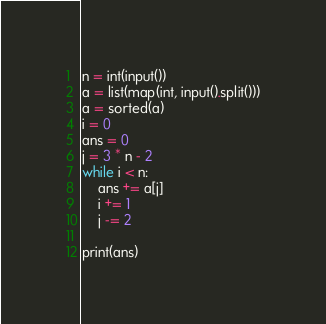Convert code to text. <code><loc_0><loc_0><loc_500><loc_500><_Python_>n = int(input())
a = list(map(int, input().split()))
a = sorted(a)
i = 0
ans = 0
j = 3 * n - 2
while i < n:
    ans += a[j]
    i += 1
    j -= 2

print(ans)</code> 